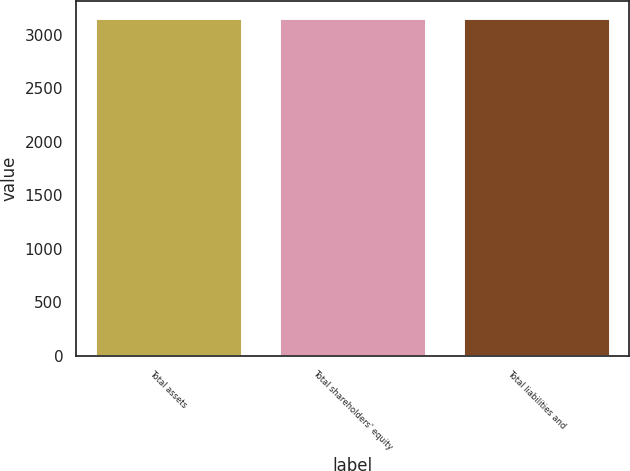<chart> <loc_0><loc_0><loc_500><loc_500><bar_chart><fcel>Total assets<fcel>Total shareholders' equity<fcel>Total liabilities and<nl><fcel>3154<fcel>3154.1<fcel>3154.2<nl></chart> 